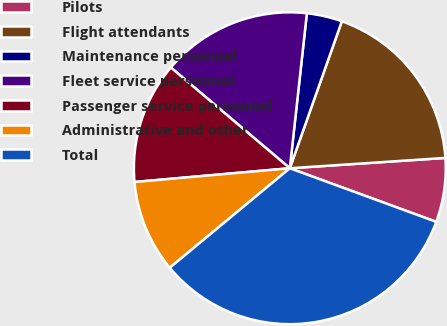Convert chart. <chart><loc_0><loc_0><loc_500><loc_500><pie_chart><fcel>Pilots<fcel>Flight attendants<fcel>Maintenance personnel<fcel>Fleet service personnel<fcel>Passenger service personnel<fcel>Administrative and other<fcel>Total<nl><fcel>6.64%<fcel>18.53%<fcel>3.67%<fcel>15.56%<fcel>12.59%<fcel>9.61%<fcel>33.4%<nl></chart> 